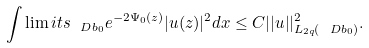<formula> <loc_0><loc_0><loc_500><loc_500>\int \lim i t s _ { \ D b _ { 0 } } e ^ { - 2 \Psi _ { 0 } ( z ) } | u ( z ) | ^ { 2 } d x \leq C | | u | | _ { L _ { 2 q } ( \ D b _ { 0 } ) } ^ { 2 } .</formula> 